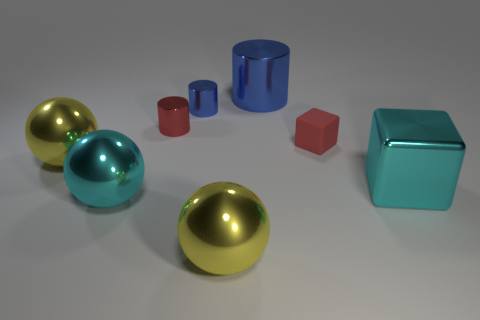Add 1 big red things. How many objects exist? 9 Subtract all balls. How many objects are left? 5 Subtract all small shiny cylinders. Subtract all blue metallic cylinders. How many objects are left? 4 Add 6 red rubber cubes. How many red rubber cubes are left? 7 Add 5 large yellow balls. How many large yellow balls exist? 7 Subtract 0 blue blocks. How many objects are left? 8 